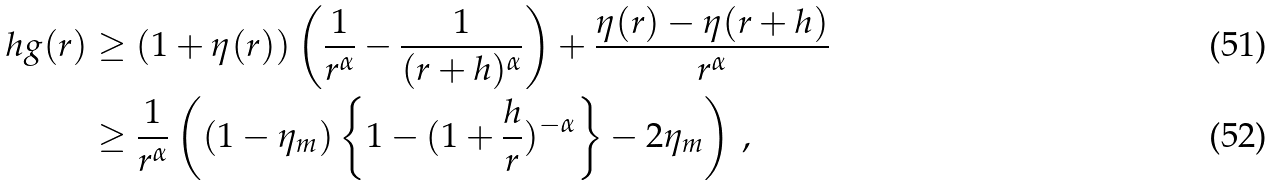Convert formula to latex. <formula><loc_0><loc_0><loc_500><loc_500>h g ( r ) & \geq ( 1 + \eta ( r ) ) \left ( \frac { 1 } { r ^ { \alpha } } - \frac { 1 } { ( r + h ) ^ { \alpha } } \right ) + \frac { \eta ( r ) - \eta ( r + h ) } { r ^ { \alpha } } \\ & \geq \frac { 1 } { r ^ { \alpha } } \left ( ( 1 - \eta _ { m } ) \left \{ 1 - ( 1 + \frac { h } { r } ) ^ { - \alpha } \right \} - 2 \eta _ { m } \right ) \, ,</formula> 